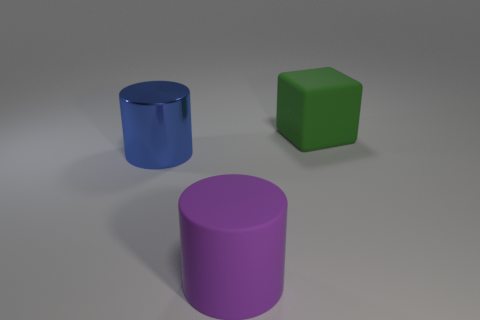Add 1 green objects. How many objects exist? 4 Subtract all cylinders. How many objects are left? 1 Subtract 0 blue blocks. How many objects are left? 3 Subtract all large rubber cubes. Subtract all big green shiny objects. How many objects are left? 2 Add 3 blue things. How many blue things are left? 4 Add 1 tiny matte cylinders. How many tiny matte cylinders exist? 1 